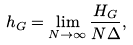<formula> <loc_0><loc_0><loc_500><loc_500>h _ { G } = \lim _ { N \rightarrow \infty } \frac { H _ { G } } { N \Delta } ,</formula> 